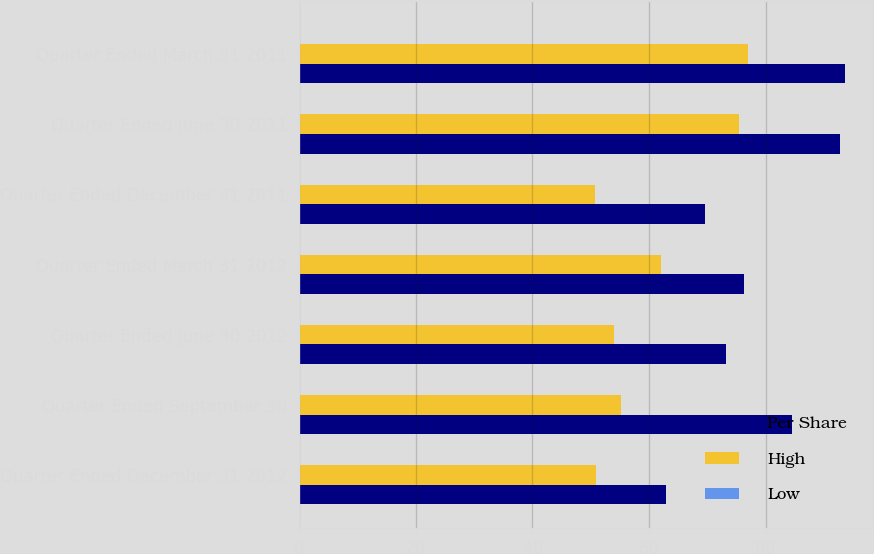Convert chart. <chart><loc_0><loc_0><loc_500><loc_500><stacked_bar_chart><ecel><fcel>Quarter Ended December 31 2012<fcel>Quarter Ended September 30<fcel>Quarter Ended June 30 2012<fcel>Quarter Ended March 31 2012<fcel>Quarter Ended December 31 2011<fcel>Quarter Ended June 30 2011<fcel>Quarter Ended March 31 2011<nl><fcel>Per Share<fcel>63<fcel>84.52<fcel>73.14<fcel>76.34<fcel>69.55<fcel>92.69<fcel>93.55<nl><fcel>High<fcel>50.89<fcel>55.14<fcel>54.01<fcel>62.13<fcel>50.74<fcel>75.5<fcel>76.96<nl><fcel>Low<fcel>0.2<fcel>0.17<fcel>0.2<fcel>0.2<fcel>0.17<fcel>0.17<fcel>0.16<nl></chart> 